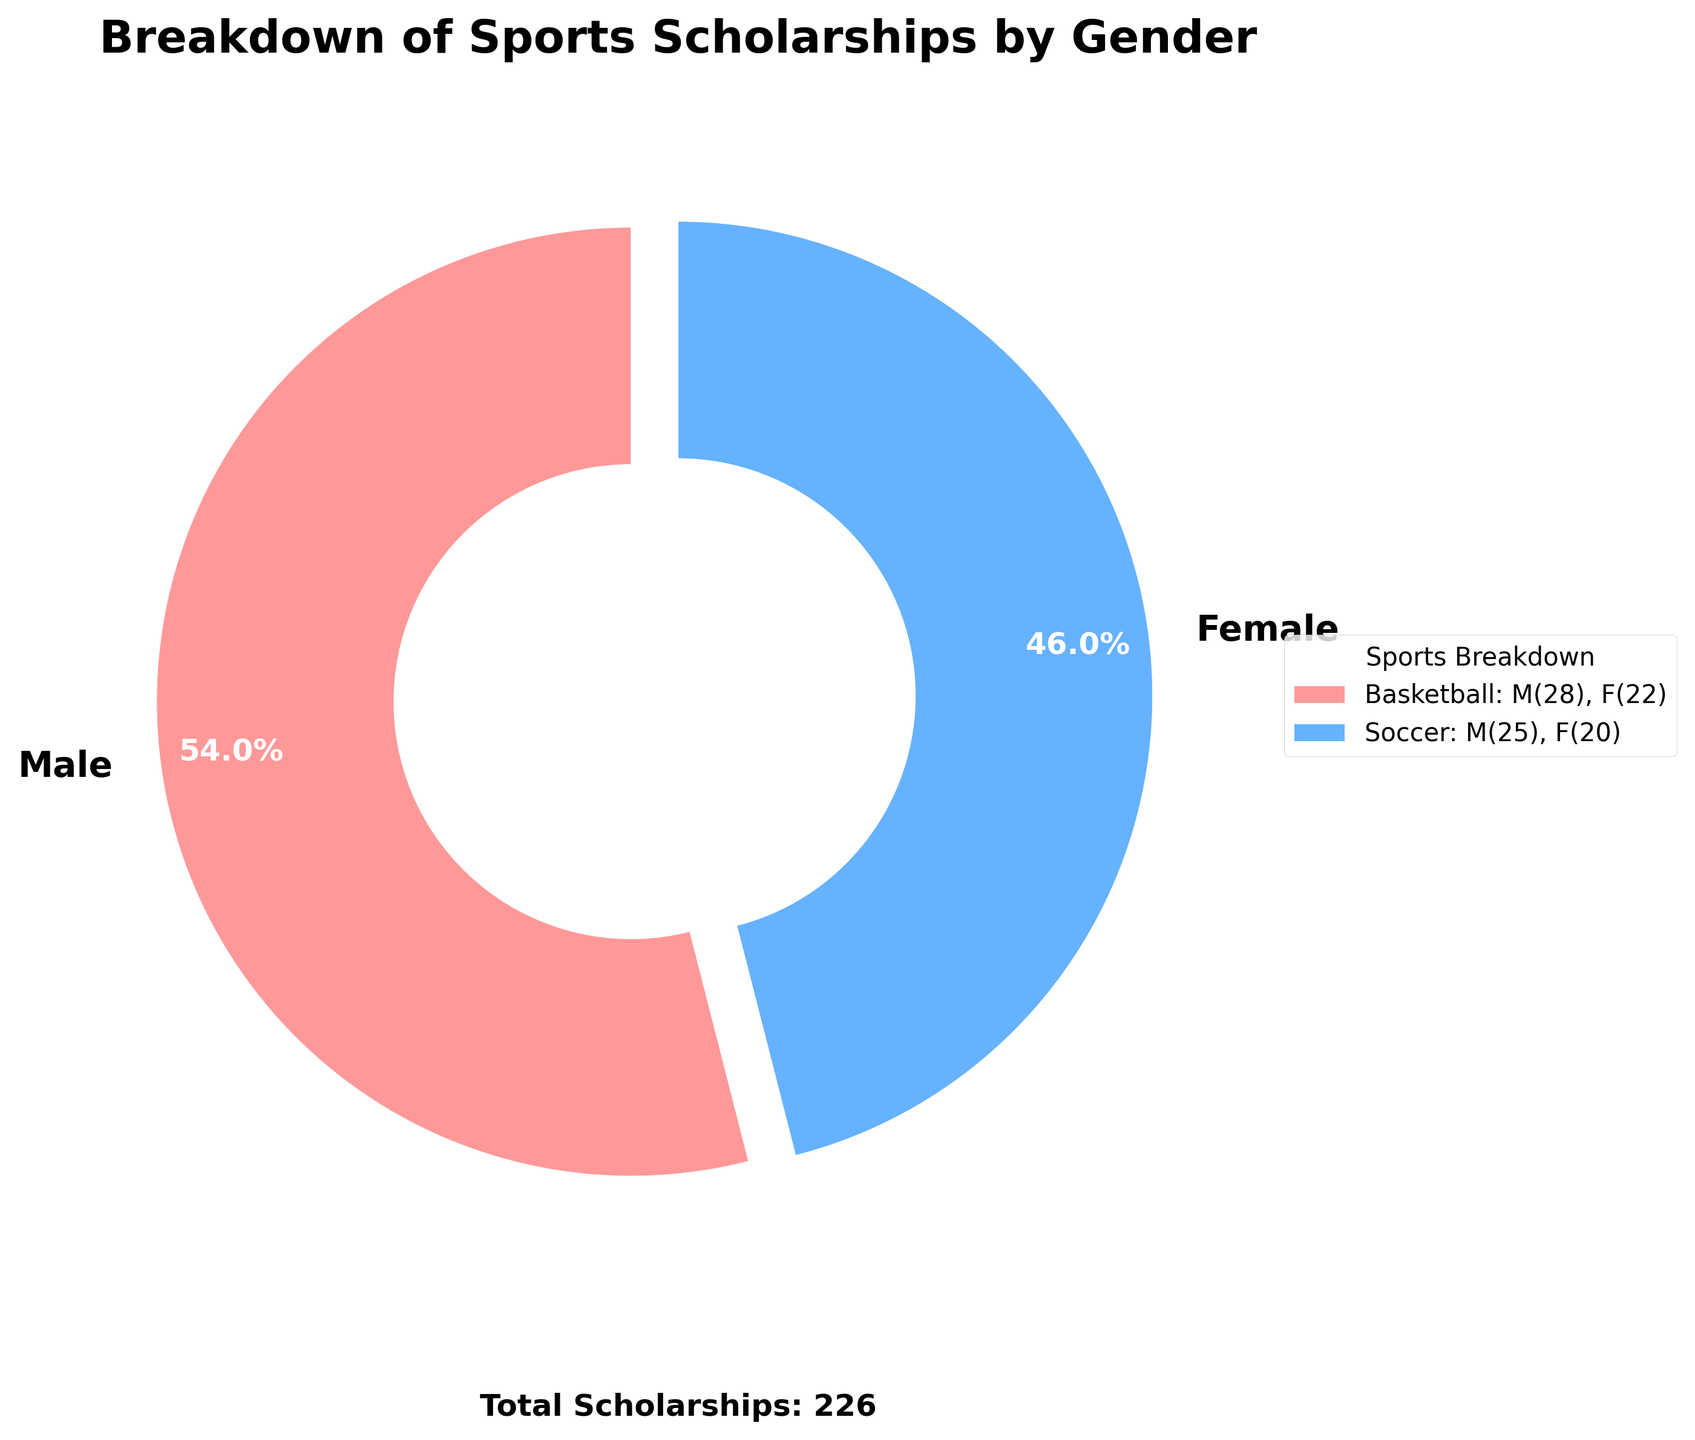How many more scholarships were awarded to male athletes compared to female athletes? The total scholarships for males are 122, and for females, it’s 104. The difference is 122 - 104 = 18.
Answer: 18 Which gender received a higher percentage of sports scholarships? The pie chart shows 54.0% for males and 46.0% for females. Males received a higher percentage.
Answer: Males In which sport did females receive more scholarships than males? Referring to the legend, Volleyball and Swimming had more scholarships for females (14 and 12) compared to males (10 and 8).
Answer: Volleyball and Swimming What is the total number of sports scholarships awarded? An annotation in the pie chart states "Total Scholarships: 226." Therefore, the total is 226.
Answer: 226 Which sport has the smallest difference in scholarships awarded between males and females? The legend shows sports with the number of scholarships: Tennis (5 M, 6 F) has a difference of 1 (6-5=1), which is the smallest difference.
Answer: Tennis If we grouped Volleyball and Swimming together, what's the percentage of scholarships awarded to females in these sports? Female scholarships in Volleyball (14) and Swimming (12) total 26. The total scholarships (226) and female scholarships overall (104). So, the percentage is (26/104) × 100 ≈ 25%.
Answer: 25% Between Basketball and Soccer, which sport saw a smaller gender disparity in scholarships? Basketball has 28 male and 22 female scholarships, a difference of 6. Soccer has 25 male and 20 female scholarships, a difference of 5. Soccer has a smaller disparity.
Answer: Soccer How many more male scholarships are there in Wrestling compared to Baseball/Softball? Wrestling has 9 male scholarships, and Softball/Baseball has 12. The difference is 12 - 9 = 3.
Answer: 3 What fraction of total scholarships were awarded to male athletes in team sports (Basketball, Soccer, Volleyball)? Male scholarships in team sports: Basketball (28), Soccer (25), Volleyball (10), total 63. Fraction is 63/226.
Answer: 63/226 